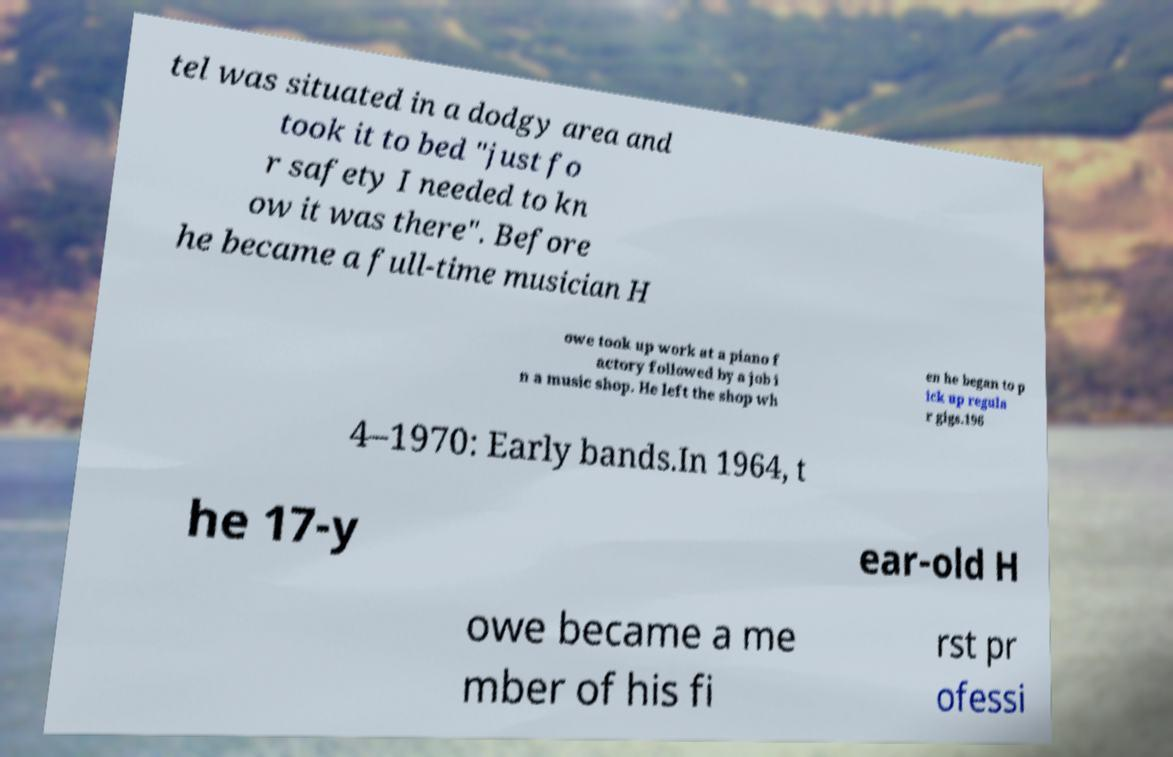Can you accurately transcribe the text from the provided image for me? tel was situated in a dodgy area and took it to bed "just fo r safety I needed to kn ow it was there". Before he became a full-time musician H owe took up work at a piano f actory followed by a job i n a music shop. He left the shop wh en he began to p ick up regula r gigs.196 4–1970: Early bands.In 1964, t he 17-y ear-old H owe became a me mber of his fi rst pr ofessi 